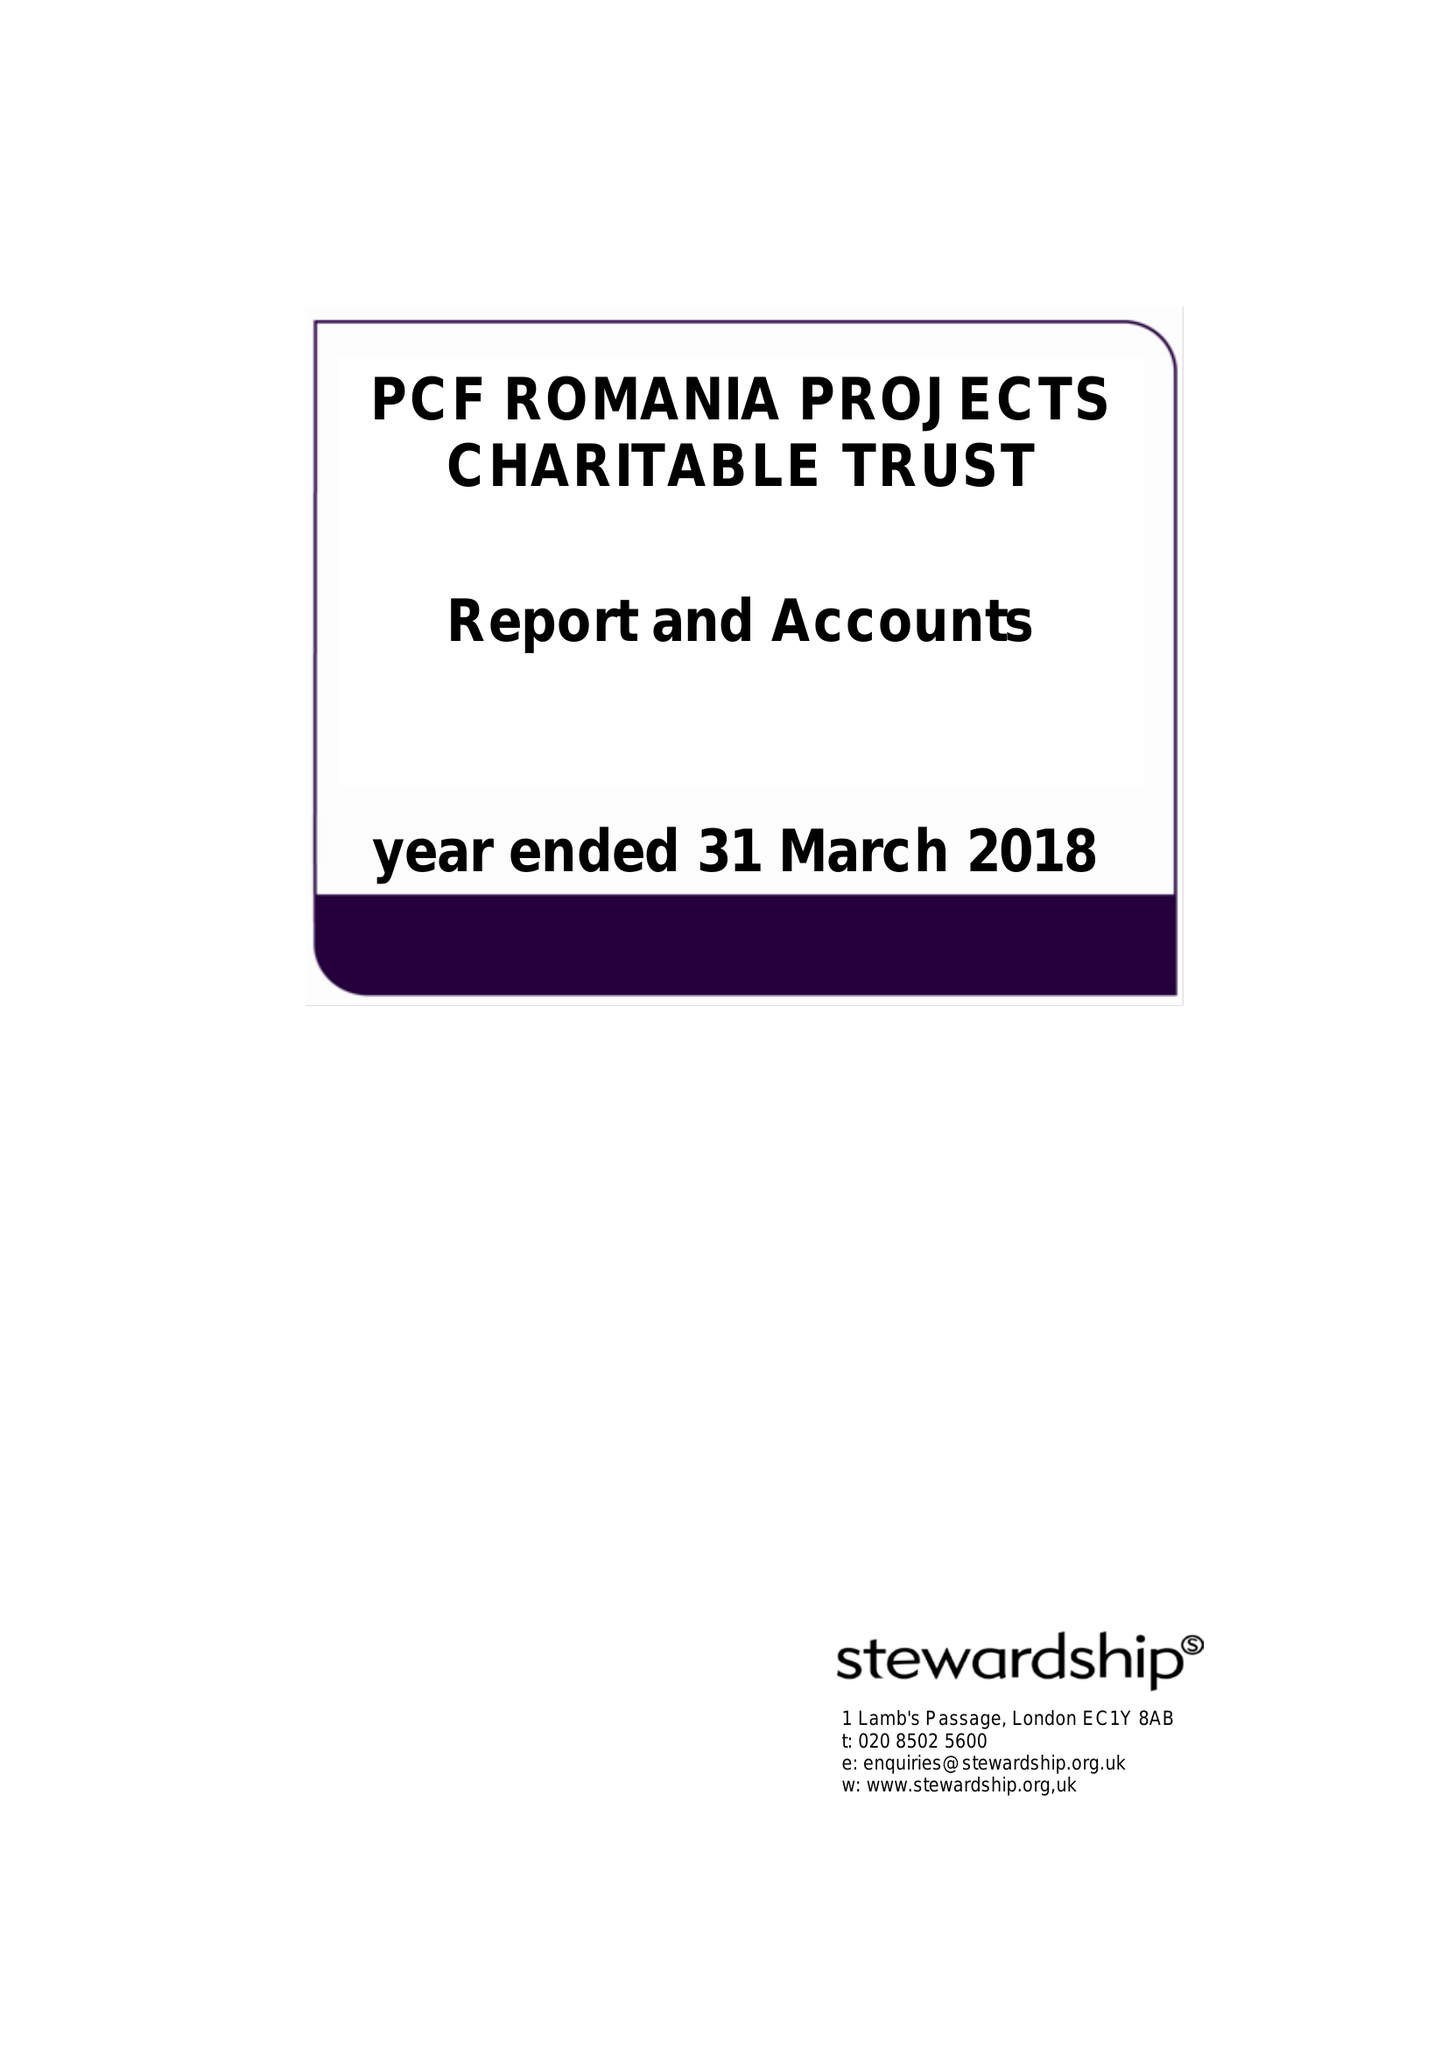What is the value for the report_date?
Answer the question using a single word or phrase. 2018-03-31 